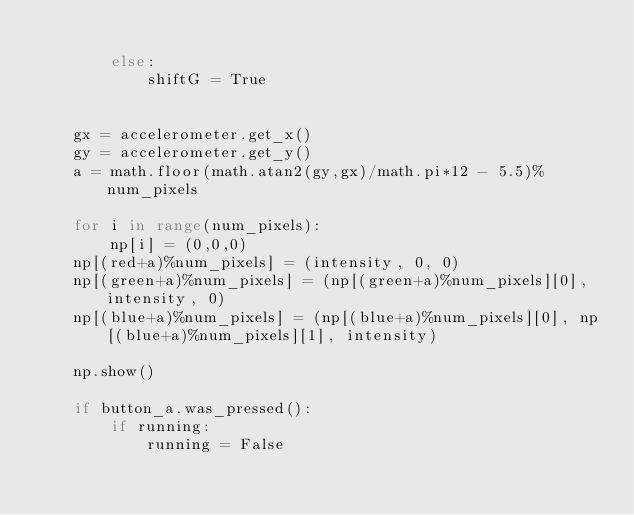Convert code to text. <code><loc_0><loc_0><loc_500><loc_500><_Python_>
        else:
            shiftG = True


    gx = accelerometer.get_x()
    gy = accelerometer.get_y()
    a = math.floor(math.atan2(gy,gx)/math.pi*12 - 5.5)%num_pixels
            
    for i in range(num_pixels):
        np[i] = (0,0,0)
    np[(red+a)%num_pixels] = (intensity, 0, 0)
    np[(green+a)%num_pixels] = (np[(green+a)%num_pixels][0], intensity, 0)
    np[(blue+a)%num_pixels] = (np[(blue+a)%num_pixels][0], np[(blue+a)%num_pixels][1], intensity)
        
    np.show()

    if button_a.was_pressed():
        if running:
            running = False</code> 